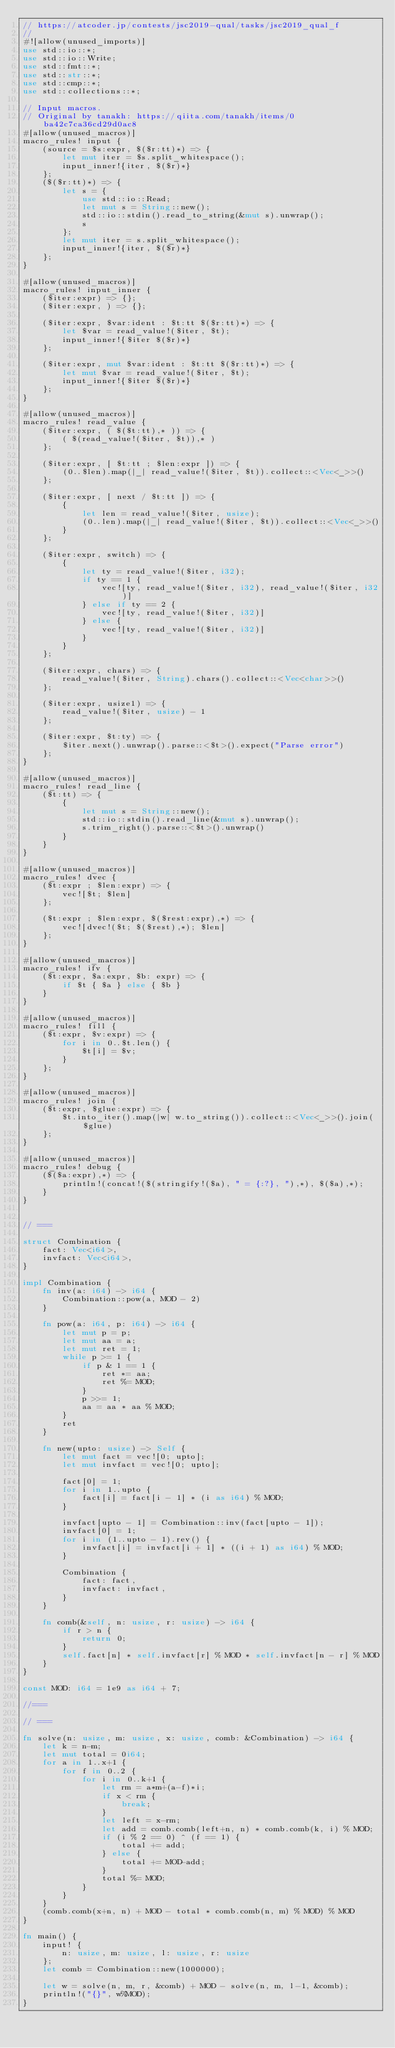Convert code to text. <code><loc_0><loc_0><loc_500><loc_500><_Rust_>// https://atcoder.jp/contests/jsc2019-qual/tasks/jsc2019_qual_f
//
#![allow(unused_imports)]
use std::io::*;
use std::io::Write;
use std::fmt::*;
use std::str::*;
use std::cmp::*;
use std::collections::*;

// Input macros.
// Original by tanakh: https://qiita.com/tanakh/items/0ba42c7ca36cd29d0ac8
#[allow(unused_macros)]
macro_rules! input {
    (source = $s:expr, $($r:tt)*) => {
        let mut iter = $s.split_whitespace();
        input_inner!{iter, $($r)*}
    };
    ($($r:tt)*) => {
        let s = {
            use std::io::Read;
            let mut s = String::new();
            std::io::stdin().read_to_string(&mut s).unwrap();
            s
        };
        let mut iter = s.split_whitespace();
        input_inner!{iter, $($r)*}
    };
}

#[allow(unused_macros)]
macro_rules! input_inner {
    ($iter:expr) => {};
    ($iter:expr, ) => {};

    ($iter:expr, $var:ident : $t:tt $($r:tt)*) => {
        let $var = read_value!($iter, $t);
        input_inner!{$iter $($r)*}
    };

    ($iter:expr, mut $var:ident : $t:tt $($r:tt)*) => {
        let mut $var = read_value!($iter, $t);
        input_inner!{$iter $($r)*}
    };
}

#[allow(unused_macros)]
macro_rules! read_value {
    ($iter:expr, ( $($t:tt),* )) => {
        ( $(read_value!($iter, $t)),* )
    };

    ($iter:expr, [ $t:tt ; $len:expr ]) => {
        (0..$len).map(|_| read_value!($iter, $t)).collect::<Vec<_>>()
    };

    ($iter:expr, [ next / $t:tt ]) => {
        {
            let len = read_value!($iter, usize);
            (0..len).map(|_| read_value!($iter, $t)).collect::<Vec<_>>()
        }
    };

    ($iter:expr, switch) => {
        {
            let ty = read_value!($iter, i32);
            if ty == 1 {
                vec![ty, read_value!($iter, i32), read_value!($iter, i32)]
            } else if ty == 2 {
                vec![ty, read_value!($iter, i32)]
            } else {
                vec![ty, read_value!($iter, i32)]
            }
        }
    };

    ($iter:expr, chars) => {
        read_value!($iter, String).chars().collect::<Vec<char>>()
    };

    ($iter:expr, usize1) => {
        read_value!($iter, usize) - 1
    };

    ($iter:expr, $t:ty) => {
        $iter.next().unwrap().parse::<$t>().expect("Parse error")
    };
}

#[allow(unused_macros)]
macro_rules! read_line {
    ($t:tt) => {
        {
            let mut s = String::new();
            std::io::stdin().read_line(&mut s).unwrap();
            s.trim_right().parse::<$t>().unwrap()
        }
    }
}

#[allow(unused_macros)]
macro_rules! dvec {
    ($t:expr ; $len:expr) => {
        vec![$t; $len]
    };

    ($t:expr ; $len:expr, $($rest:expr),*) => {
        vec![dvec!($t; $($rest),*); $len]
    };
}

#[allow(unused_macros)]
macro_rules! ifv {
    ($t:expr, $a:expr, $b: expr) => {
        if $t { $a } else { $b }
    }
}

#[allow(unused_macros)]
macro_rules! fill {
    ($t:expr, $v:expr) => {
        for i in 0..$t.len() {
            $t[i] = $v;
        }
    };
}

#[allow(unused_macros)]
macro_rules! join {
    ($t:expr, $glue:expr) => {
        $t.into_iter().map(|w| w.to_string()).collect::<Vec<_>>().join($glue)
    };
}

#[allow(unused_macros)]
macro_rules! debug {
    ($($a:expr),*) => {
        println!(concat!($(stringify!($a), " = {:?}, "),*), $($a),*);
    }
}


// ===

struct Combination {
    fact: Vec<i64>,
    invfact: Vec<i64>,
}

impl Combination {
    fn inv(a: i64) -> i64 {
        Combination::pow(a, MOD - 2)
    }

    fn pow(a: i64, p: i64) -> i64 {
        let mut p = p;
        let mut aa = a;
        let mut ret = 1;
        while p >= 1 {
            if p & 1 == 1 {
                ret *= aa;
                ret %= MOD;
            }
            p >>= 1;
            aa = aa * aa % MOD;
        }
        ret
    }

    fn new(upto: usize) -> Self {
        let mut fact = vec![0; upto];
        let mut invfact = vec![0; upto];

        fact[0] = 1;
        for i in 1..upto {
            fact[i] = fact[i - 1] * (i as i64) % MOD;
        }

        invfact[upto - 1] = Combination::inv(fact[upto - 1]);
        invfact[0] = 1;
        for i in (1..upto - 1).rev() {
            invfact[i] = invfact[i + 1] * ((i + 1) as i64) % MOD;
        }

        Combination {
            fact: fact,
            invfact: invfact,
        }
    }

    fn comb(&self, n: usize, r: usize) -> i64 {
        if r > n {
            return 0;
        }
        self.fact[n] * self.invfact[r] % MOD * self.invfact[n - r] % MOD
    }
}

const MOD: i64 = 1e9 as i64 + 7;

//===

// ===

fn solve(n: usize, m: usize, x: usize, comb: &Combination) -> i64 {
    let k = n-m;
    let mut total = 0i64;
    for a in 1..x+1 {
        for f in 0..2 {
            for i in 0..k+1 {
                let rm = a*m+(a-f)*i;
                if x < rm {
                    break;
                }
                let left = x-rm;
                let add = comb.comb(left+n, n) * comb.comb(k, i) % MOD;
                if (i % 2 == 0) ^ (f == 1) {
                    total += add;
                } else {
                    total += MOD-add;
                }
                total %= MOD;
            }
        }
    }
    (comb.comb(x+n, n) + MOD - total * comb.comb(n, m) % MOD) % MOD
}

fn main() {
    input! {
        n: usize, m: usize, l: usize, r: usize
    };
    let comb = Combination::new(1000000);

    let w = solve(n, m, r, &comb) + MOD - solve(n, m, l-1, &comb);
    println!("{}", w%MOD);
}
</code> 